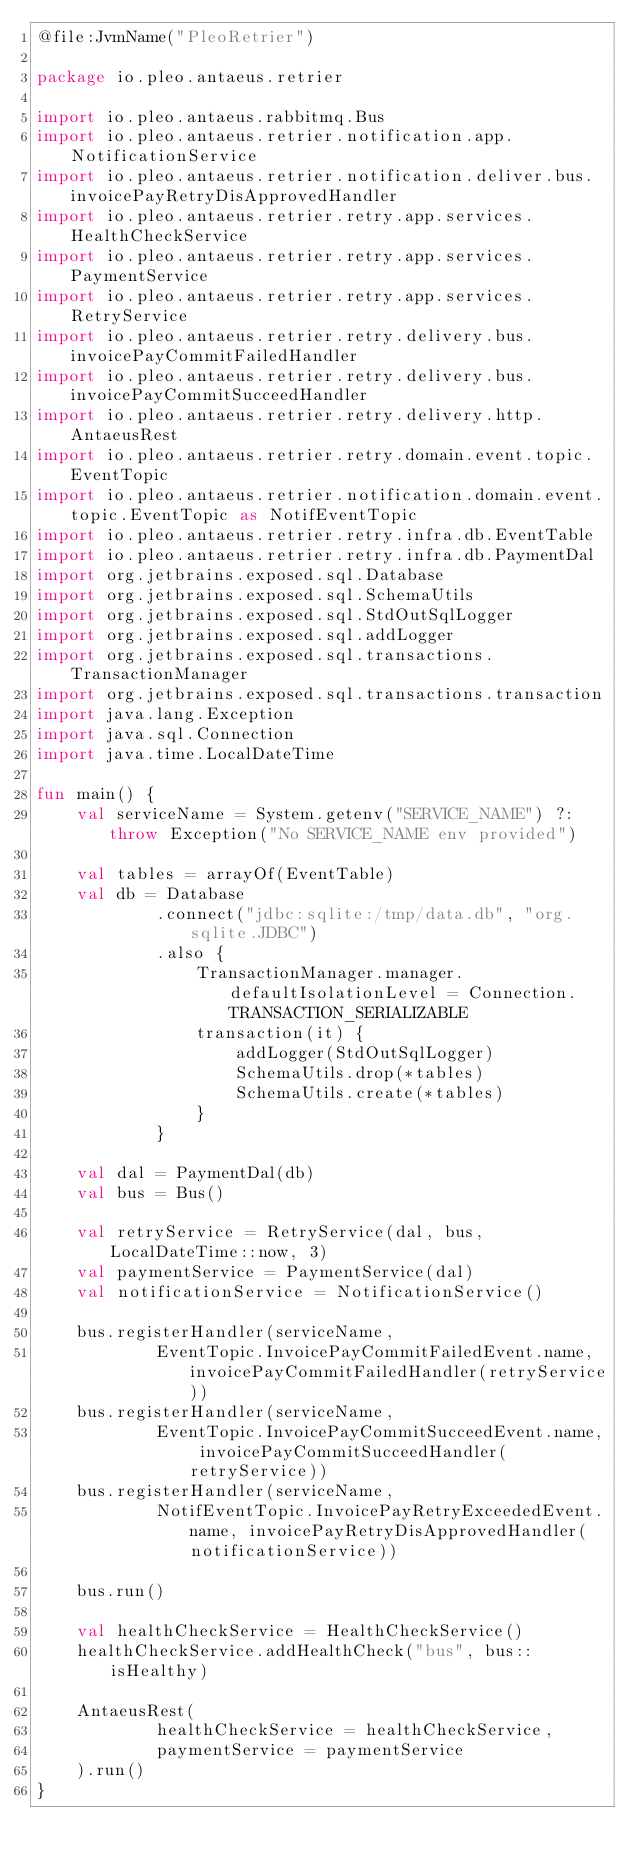<code> <loc_0><loc_0><loc_500><loc_500><_Kotlin_>@file:JvmName("PleoRetrier")

package io.pleo.antaeus.retrier

import io.pleo.antaeus.rabbitmq.Bus
import io.pleo.antaeus.retrier.notification.app.NotificationService
import io.pleo.antaeus.retrier.notification.deliver.bus.invoicePayRetryDisApprovedHandler
import io.pleo.antaeus.retrier.retry.app.services.HealthCheckService
import io.pleo.antaeus.retrier.retry.app.services.PaymentService
import io.pleo.antaeus.retrier.retry.app.services.RetryService
import io.pleo.antaeus.retrier.retry.delivery.bus.invoicePayCommitFailedHandler
import io.pleo.antaeus.retrier.retry.delivery.bus.invoicePayCommitSucceedHandler
import io.pleo.antaeus.retrier.retry.delivery.http.AntaeusRest
import io.pleo.antaeus.retrier.retry.domain.event.topic.EventTopic
import io.pleo.antaeus.retrier.notification.domain.event.topic.EventTopic as NotifEventTopic
import io.pleo.antaeus.retrier.retry.infra.db.EventTable
import io.pleo.antaeus.retrier.retry.infra.db.PaymentDal
import org.jetbrains.exposed.sql.Database
import org.jetbrains.exposed.sql.SchemaUtils
import org.jetbrains.exposed.sql.StdOutSqlLogger
import org.jetbrains.exposed.sql.addLogger
import org.jetbrains.exposed.sql.transactions.TransactionManager
import org.jetbrains.exposed.sql.transactions.transaction
import java.lang.Exception
import java.sql.Connection
import java.time.LocalDateTime

fun main() {
    val serviceName = System.getenv("SERVICE_NAME") ?: throw Exception("No SERVICE_NAME env provided")

    val tables = arrayOf(EventTable)
    val db = Database
            .connect("jdbc:sqlite:/tmp/data.db", "org.sqlite.JDBC")
            .also {
                TransactionManager.manager.defaultIsolationLevel = Connection.TRANSACTION_SERIALIZABLE
                transaction(it) {
                    addLogger(StdOutSqlLogger)
                    SchemaUtils.drop(*tables)
                    SchemaUtils.create(*tables)
                }
            }

    val dal = PaymentDal(db)
    val bus = Bus()

    val retryService = RetryService(dal, bus, LocalDateTime::now, 3)
    val paymentService = PaymentService(dal)
    val notificationService = NotificationService()

    bus.registerHandler(serviceName,
            EventTopic.InvoicePayCommitFailedEvent.name, invoicePayCommitFailedHandler(retryService))
    bus.registerHandler(serviceName,
            EventTopic.InvoicePayCommitSucceedEvent.name, invoicePayCommitSucceedHandler(retryService))
    bus.registerHandler(serviceName,
            NotifEventTopic.InvoicePayRetryExceededEvent.name, invoicePayRetryDisApprovedHandler(notificationService))

    bus.run()

    val healthCheckService = HealthCheckService()
    healthCheckService.addHealthCheck("bus", bus::isHealthy)

    AntaeusRest(
            healthCheckService = healthCheckService,
            paymentService = paymentService
    ).run()
}</code> 